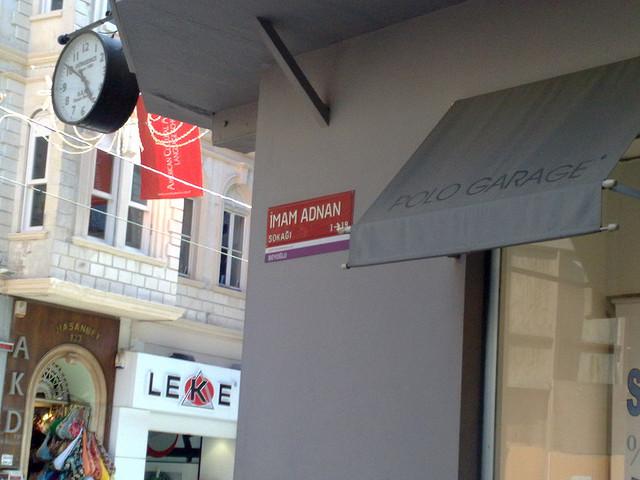What flag is on the store's sign?
Short answer required. Red. What time does the clock on the rear wall read?
Quick response, please. 4:50. What type of sign is outside the window?
Short answer required. Imam adnan. What country does this scene appear to be out of?
Write a very short answer. Turkey. How many clocks are shaped like a triangle?
Give a very brief answer. 0. What time does the clock say?
Short answer required. 4:50. What is the store name printed on?
Answer briefly. Polo garage. Is the building residential or commercial?
Be succinct. Commercial. Is there an overhang over the window?
Answer briefly. Yes. 